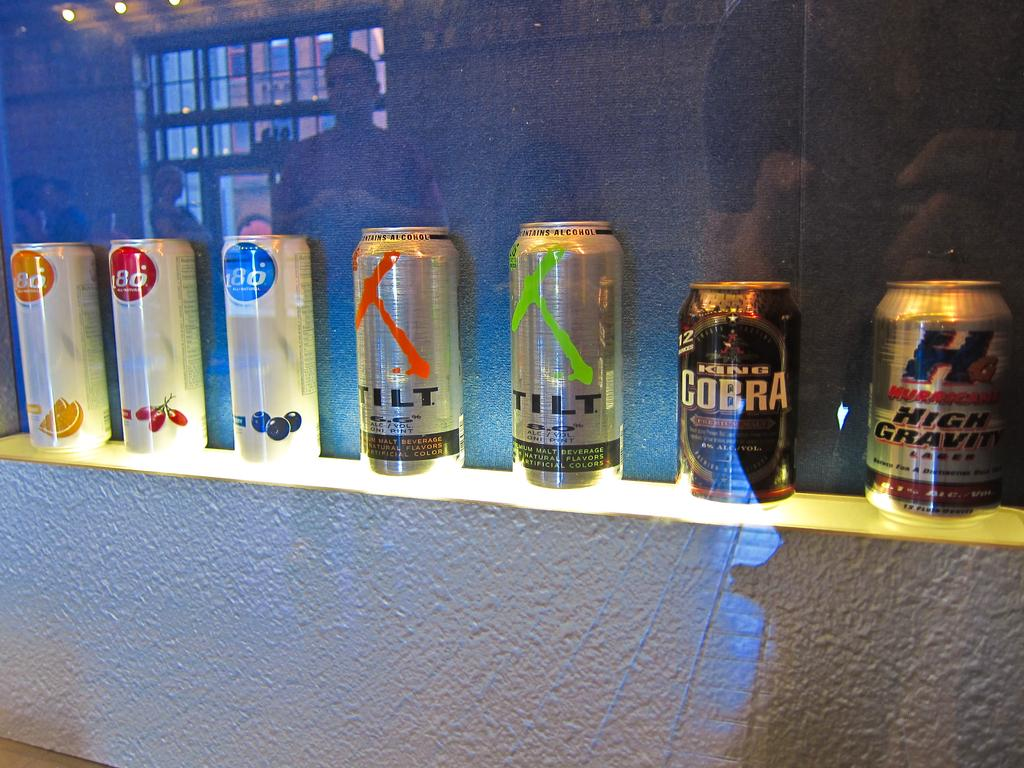<image>
Give a short and clear explanation of the subsequent image. cans of TILT, KING COBRA, HIGH GRAVITY & 180 beverages on display. 